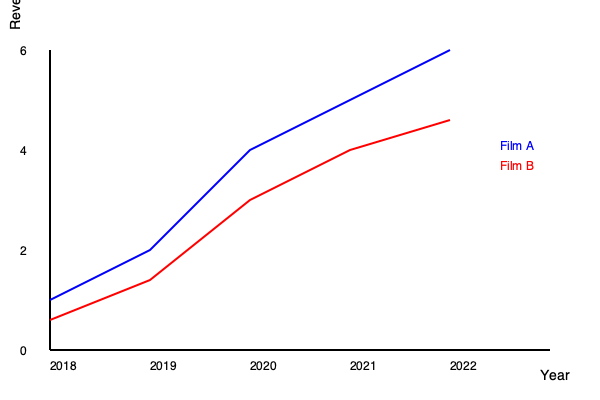As a financial analyst in the film industry, you're tasked with comparing the box office performance of two blockbuster film franchises over the past five years. Based on the line graph showing the annual revenue for Film A and Film B from 2018 to 2022, calculate the total difference in revenue between the two franchises over this period. Express your answer in billions of dollars. To solve this problem, we need to follow these steps:

1. Determine the revenue for each film in each year:

   2018: Film A = $1B, Film B = $0.6B
   2019: Film A = $2B, Film B = $1.4B
   2020: Film A = $4B, Film B = $3B
   2021: Film A = $5B, Film B = $4B
   2022: Film A = $6B, Film B = $4.6B

2. Calculate the difference in revenue for each year:

   2018: $1B - $0.6B = $0.4B
   2019: $2B - $1.4B = $0.6B
   2020: $4B - $3B = $1B
   2021: $5B - $4B = $1B
   2022: $6B - $4.6B = $1.4B

3. Sum up the differences:

   Total difference = $0.4B + $0.6B + $1B + $1B + $1.4B = $4.4B

Therefore, the total difference in revenue between Film A and Film B over the five-year period is $4.4 billion.
Answer: $4.4 billion 